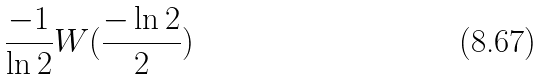<formula> <loc_0><loc_0><loc_500><loc_500>\frac { - 1 } { \ln 2 } W ( \frac { - \ln 2 } { 2 } )</formula> 